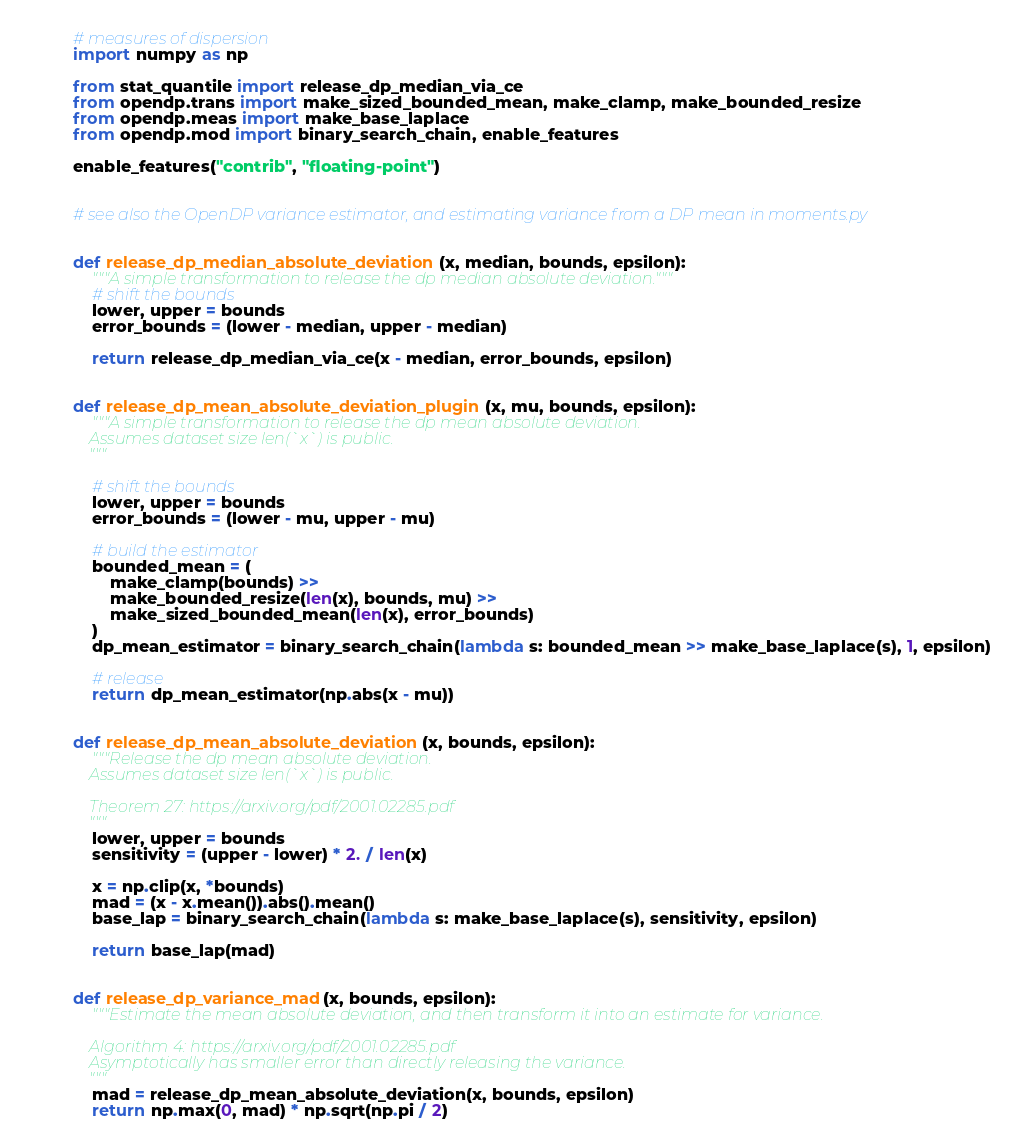Convert code to text. <code><loc_0><loc_0><loc_500><loc_500><_Python_># measures of dispersion
import numpy as np

from stat_quantile import release_dp_median_via_ce
from opendp.trans import make_sized_bounded_mean, make_clamp, make_bounded_resize
from opendp.meas import make_base_laplace
from opendp.mod import binary_search_chain, enable_features

enable_features("contrib", "floating-point")


# see also the OpenDP variance estimator, and estimating variance from a DP mean in moments.py


def release_dp_median_absolute_deviation(x, median, bounds, epsilon):
    """A simple transformation to release the dp median absolute deviation."""
    # shift the bounds
    lower, upper = bounds
    error_bounds = (lower - median, upper - median)

    return release_dp_median_via_ce(x - median, error_bounds, epsilon)


def release_dp_mean_absolute_deviation_plugin(x, mu, bounds, epsilon):
    """A simple transformation to release the dp mean absolute deviation.
    Assumes dataset size len(`x`) is public.
    """

    # shift the bounds
    lower, upper = bounds
    error_bounds = (lower - mu, upper - mu)

    # build the estimator
    bounded_mean = (
        make_clamp(bounds) >> 
        make_bounded_resize(len(x), bounds, mu) >>
        make_sized_bounded_mean(len(x), error_bounds)
    )
    dp_mean_estimator = binary_search_chain(lambda s: bounded_mean >> make_base_laplace(s), 1, epsilon)

    # release
    return dp_mean_estimator(np.abs(x - mu))


def release_dp_mean_absolute_deviation(x, bounds, epsilon):
    """Release the dp mean absolute deviation.
    Assumes dataset size len(`x`) is public.

    Theorem 27: https://arxiv.org/pdf/2001.02285.pdf
    """
    lower, upper = bounds
    sensitivity = (upper - lower) * 2. / len(x)

    x = np.clip(x, *bounds)
    mad = (x - x.mean()).abs().mean()
    base_lap = binary_search_chain(lambda s: make_base_laplace(s), sensitivity, epsilon)

    return base_lap(mad)


def release_dp_variance_mad(x, bounds, epsilon):
    """Estimate the mean absolute deviation, and then transform it into an estimate for variance.

    Algorithm 4: https://arxiv.org/pdf/2001.02285.pdf
    Asymptotically has smaller error than directly releasing the variance.
    """
    mad = release_dp_mean_absolute_deviation(x, bounds, epsilon)
    return np.max(0, mad) * np.sqrt(np.pi / 2)
</code> 